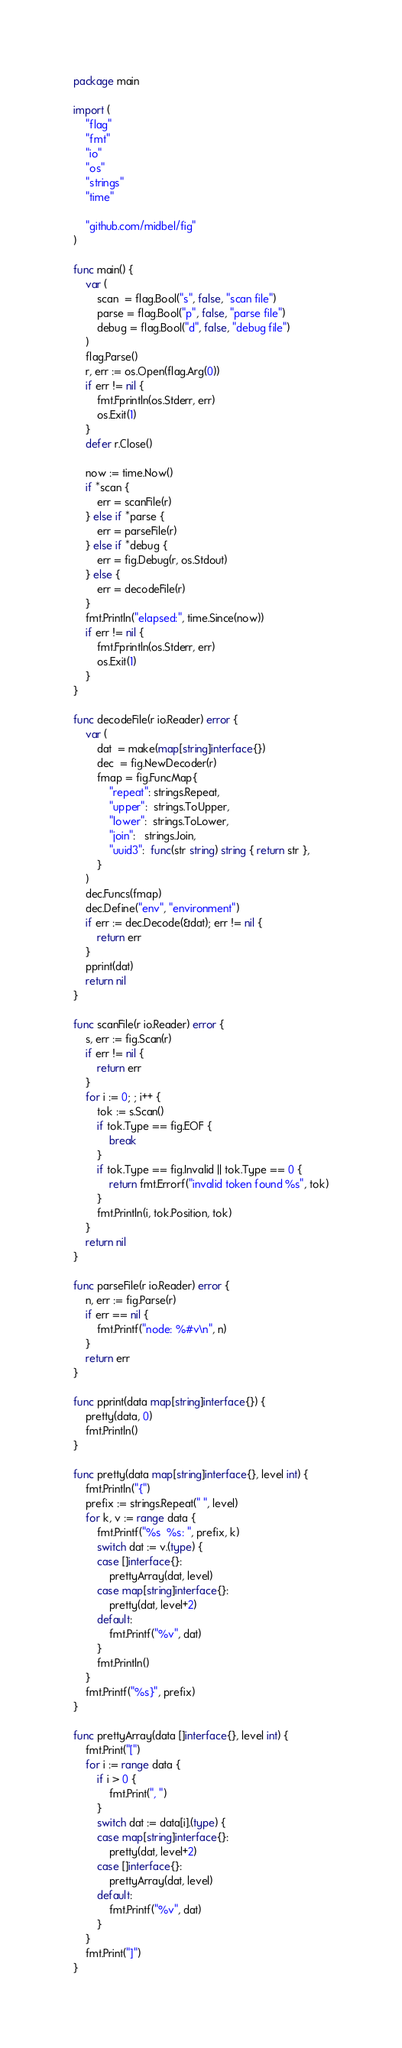Convert code to text. <code><loc_0><loc_0><loc_500><loc_500><_Go_>package main

import (
	"flag"
	"fmt"
	"io"
	"os"
	"strings"
	"time"

	"github.com/midbel/fig"
)

func main() {
	var (
		scan  = flag.Bool("s", false, "scan file")
		parse = flag.Bool("p", false, "parse file")
		debug = flag.Bool("d", false, "debug file")
	)
	flag.Parse()
	r, err := os.Open(flag.Arg(0))
	if err != nil {
		fmt.Fprintln(os.Stderr, err)
		os.Exit(1)
	}
	defer r.Close()

	now := time.Now()
	if *scan {
		err = scanFile(r)
	} else if *parse {
		err = parseFile(r)
	} else if *debug {
		err = fig.Debug(r, os.Stdout)
	} else {
		err = decodeFile(r)
	}
	fmt.Println("elapsed:", time.Since(now))
	if err != nil {
		fmt.Fprintln(os.Stderr, err)
		os.Exit(1)
	}
}

func decodeFile(r io.Reader) error {
	var (
		dat  = make(map[string]interface{})
		dec  = fig.NewDecoder(r)
		fmap = fig.FuncMap{
			"repeat": strings.Repeat,
			"upper":  strings.ToUpper,
			"lower":  strings.ToLower,
			"join":   strings.Join,
			"uuid3":  func(str string) string { return str },
		}
	)
	dec.Funcs(fmap)
	dec.Define("env", "environment")
	if err := dec.Decode(&dat); err != nil {
		return err
	}
	pprint(dat)
	return nil
}

func scanFile(r io.Reader) error {
	s, err := fig.Scan(r)
	if err != nil {
		return err
	}
	for i := 0; ; i++ {
		tok := s.Scan()
		if tok.Type == fig.EOF {
			break
		}
		if tok.Type == fig.Invalid || tok.Type == 0 {
			return fmt.Errorf("invalid token found %s", tok)
		}
		fmt.Println(i, tok.Position, tok)
	}
	return nil
}

func parseFile(r io.Reader) error {
	n, err := fig.Parse(r)
	if err == nil {
		fmt.Printf("node: %#v\n", n)
	}
	return err
}

func pprint(data map[string]interface{}) {
	pretty(data, 0)
	fmt.Println()
}

func pretty(data map[string]interface{}, level int) {
	fmt.Println("{")
	prefix := strings.Repeat(" ", level)
	for k, v := range data {
		fmt.Printf("%s  %s: ", prefix, k)
		switch dat := v.(type) {
		case []interface{}:
			prettyArray(dat, level)
		case map[string]interface{}:
			pretty(dat, level+2)
		default:
			fmt.Printf("%v", dat)
		}
		fmt.Println()
	}
	fmt.Printf("%s}", prefix)
}

func prettyArray(data []interface{}, level int) {
	fmt.Print("[")
	for i := range data {
		if i > 0 {
			fmt.Print(", ")
		}
		switch dat := data[i].(type) {
		case map[string]interface{}:
			pretty(dat, level+2)
		case []interface{}:
			prettyArray(dat, level)
		default:
			fmt.Printf("%v", dat)
		}
	}
	fmt.Print("]")
}
</code> 